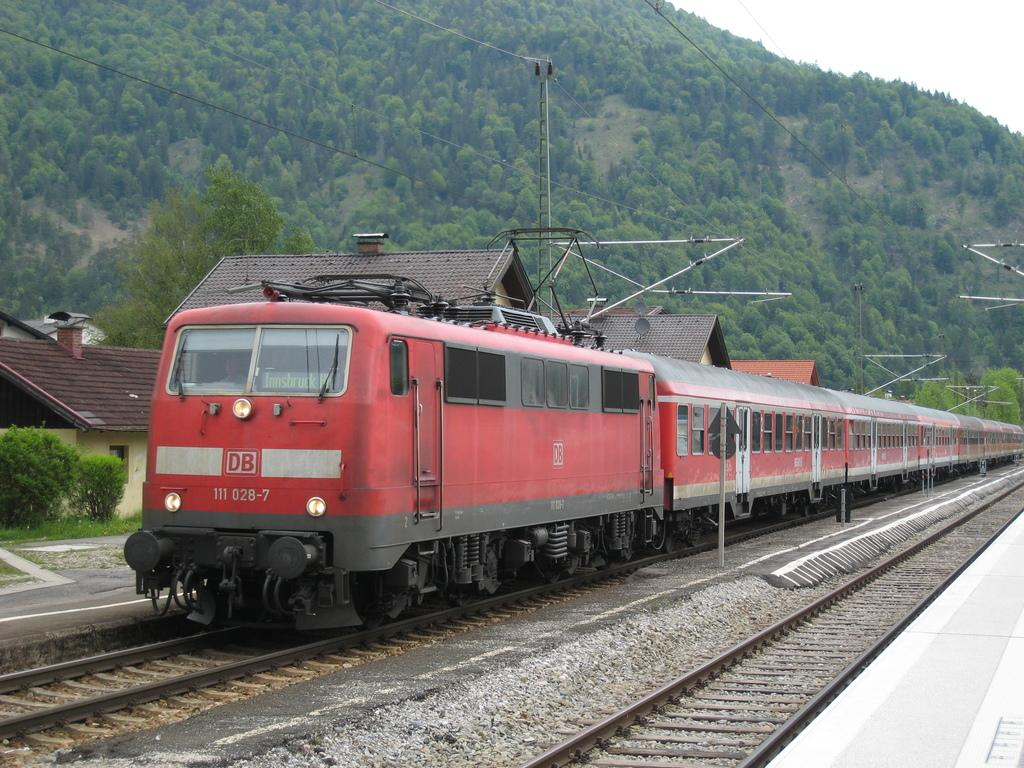<image>
Present a compact description of the photo's key features. Red train on the tracks with the letters DB on it. 